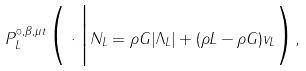Convert formula to latex. <formula><loc_0><loc_0><loc_500><loc_500>P _ { L } ^ { \circ , \beta , \mu t } \Big ( \cdot \Big | N _ { L } = \rho G | \Lambda _ { L } | + ( \rho L - \rho G ) v _ { L } \Big ) ,</formula> 